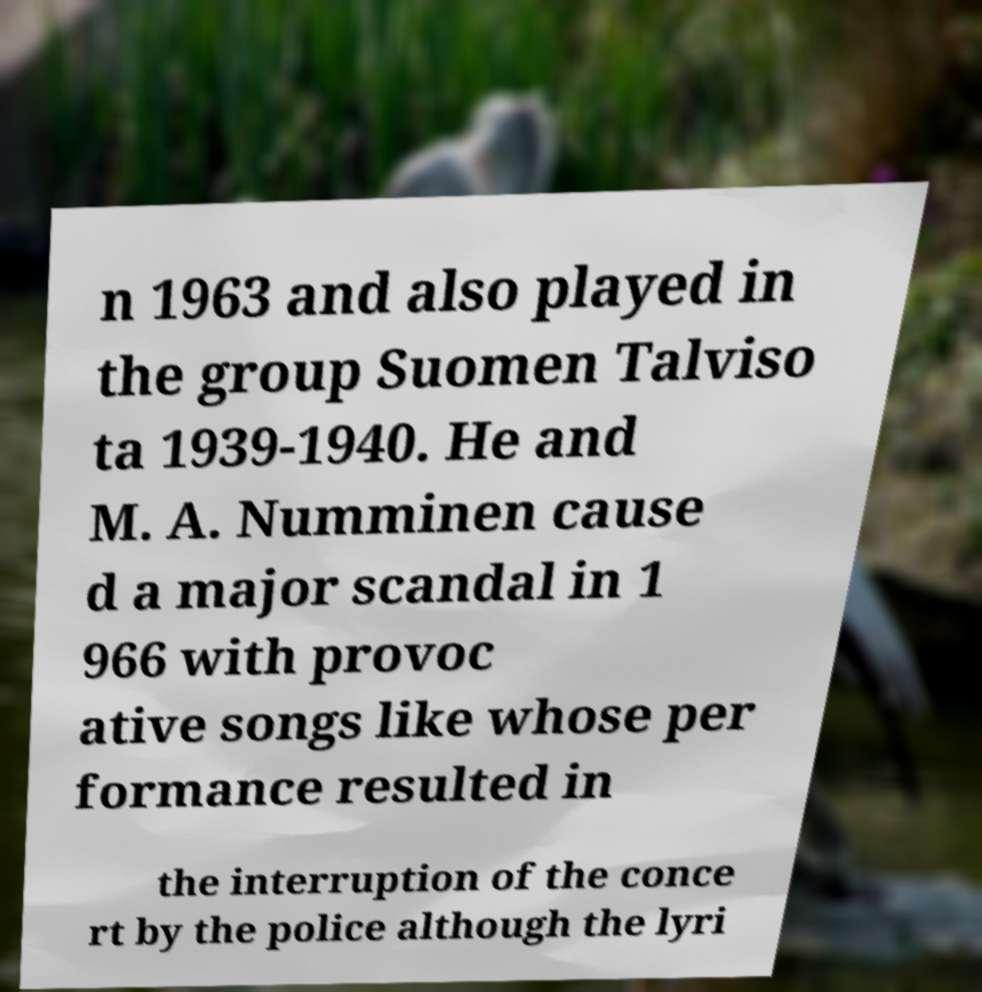For documentation purposes, I need the text within this image transcribed. Could you provide that? n 1963 and also played in the group Suomen Talviso ta 1939-1940. He and M. A. Numminen cause d a major scandal in 1 966 with provoc ative songs like whose per formance resulted in the interruption of the conce rt by the police although the lyri 